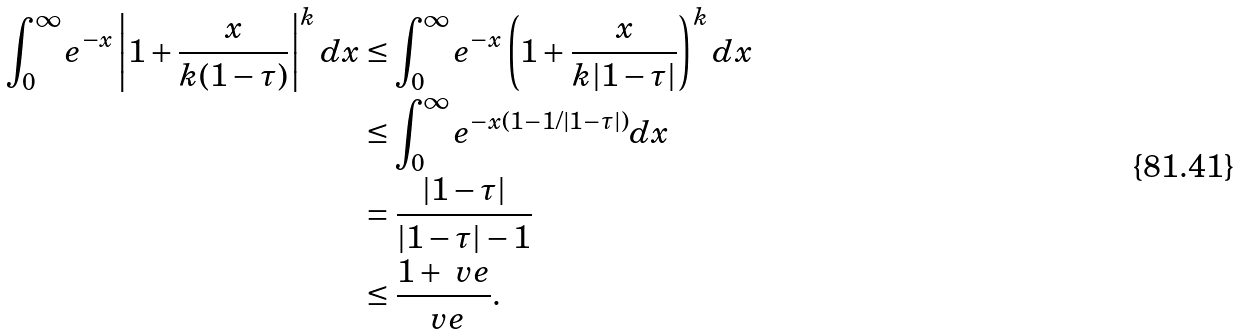Convert formula to latex. <formula><loc_0><loc_0><loc_500><loc_500>\int _ { 0 } ^ { \infty } e ^ { - x } \left | 1 + \frac { x } { k ( 1 - \tau ) } \right | ^ { k } d x & \leq \int _ { 0 } ^ { \infty } e ^ { - x } \left ( 1 + \frac { x } { k | 1 - \tau | } \right ) ^ { k } d x \\ & \leq \int _ { 0 } ^ { \infty } e ^ { - x ( 1 - 1 / | 1 - \tau | ) } d x \\ & = \frac { | 1 - \tau | } { | 1 - \tau | - 1 } \\ & \leq \frac { 1 + \ v e } { \ v e } .</formula> 